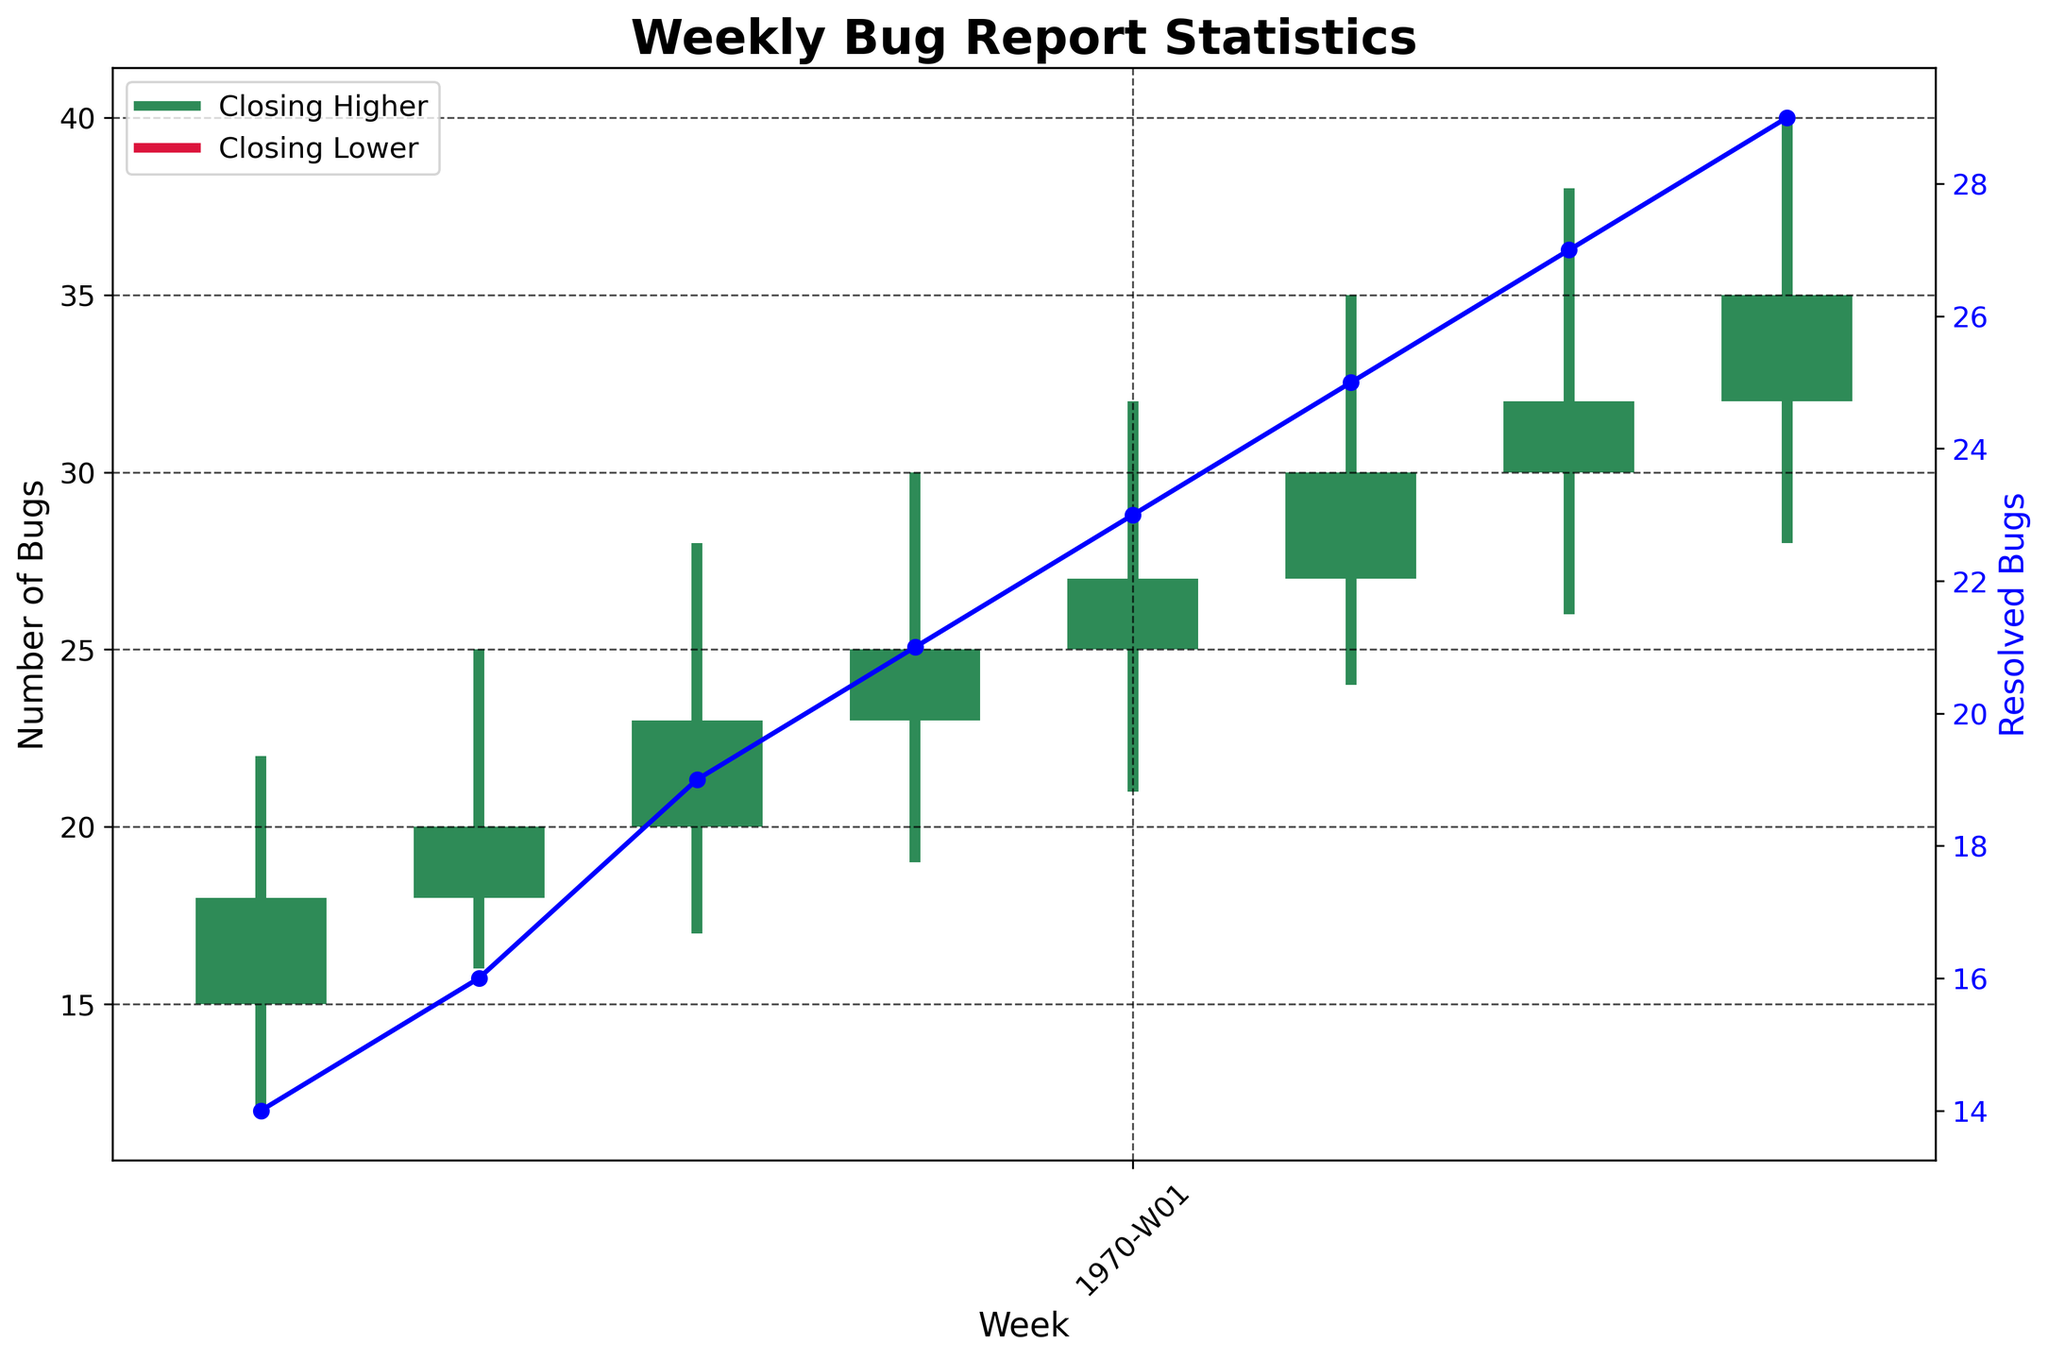What's the title of the figure? The title is located at the top of the figure and is often in larger, bold text to signify its importance and provide a summary of what the figure represents.
Answer: Weekly Bug Report Statistics How many weeks of data are displayed in the figure? By counting the number of unique data points along the x-axis, we can determine the number of weeks for which data is displayed.
Answer: 8 During which week did the number of bugs close higher? Identify the bars on the chart that are green, which indicate weeks where the closing number of bugs was higher than the opening number. There are green bars corresponding to those weeks.
Answer: 2023-W18 to 2023-W25 What is the trend of the resolved bugs over the weeks? The trend of the resolved bugs can be observed by looking at the blue line with markers plotted on the secondary y-axis. The line generally trends upwards over the weeks.
Answer: Increasing In which week were the most bugs resolved? Locate the peak of the blue line with markers, which represents the number of resolved bugs.
Answer: 2023-W25 What were the opening and closing values for the number of bugs in week 2023-W23? Find the 2023-W23 data point on the chart and look at the bottom and top ends of the corresponding bar to determine the opening and closing values.
Answer: 27 and 30 Which week had the highest high value for bugs? Look at the highest points of the vertical lines (representing the high values) and determine which week corresponds to the maximum value.
Answer: 2023-W25 What's the average close value of the bugs over the 8 weeks? Add up all the closing values provided and then divide by the number of weeks (8). 18+20+23+25+27+30+32+35 = 210, Average: 210/8 = 26.25
Answer: 26.25 Compare the number of critical bugs with major bugs in week 2023-W21. Locate the values for critical and major bugs in week 2023-W21 and compare them. There are 7 critical bugs and 11 major bugs.
Answer: Major bugs are more than critical bugs How did the count of minor bugs change from 2023-W18 to 2023-W25? Examine the minor bugs count in each of the weeks provided and note the values for 2023-W18 and 2023-W25. From 10 to 14, this shows an increase of 4.
Answer: Increased by 4 